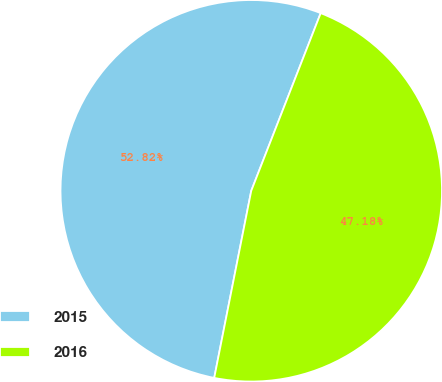Convert chart to OTSL. <chart><loc_0><loc_0><loc_500><loc_500><pie_chart><fcel>2015<fcel>2016<nl><fcel>52.82%<fcel>47.18%<nl></chart> 